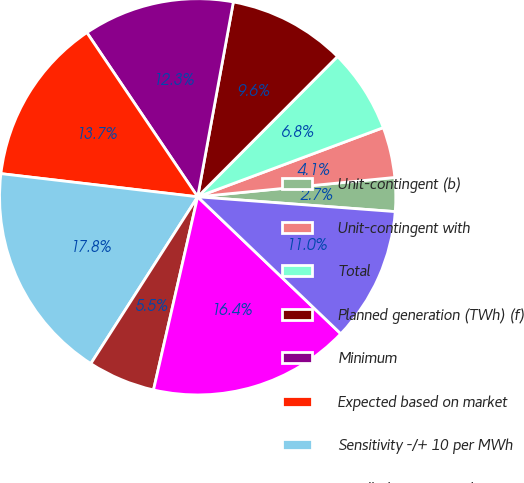Convert chart to OTSL. <chart><loc_0><loc_0><loc_500><loc_500><pie_chart><fcel>Unit-contingent (b)<fcel>Unit-contingent with<fcel>Total<fcel>Planned generation (TWh) (f)<fcel>Minimum<fcel>Expected based on market<fcel>Sensitivity -/+ 10 per MWh<fcel>Bundled capacity and energy<fcel>Planned net MW in operation<fcel>Expected sold and market total<nl><fcel>2.75%<fcel>4.12%<fcel>6.85%<fcel>9.59%<fcel>12.33%<fcel>13.69%<fcel>17.8%<fcel>5.49%<fcel>16.43%<fcel>10.96%<nl></chart> 